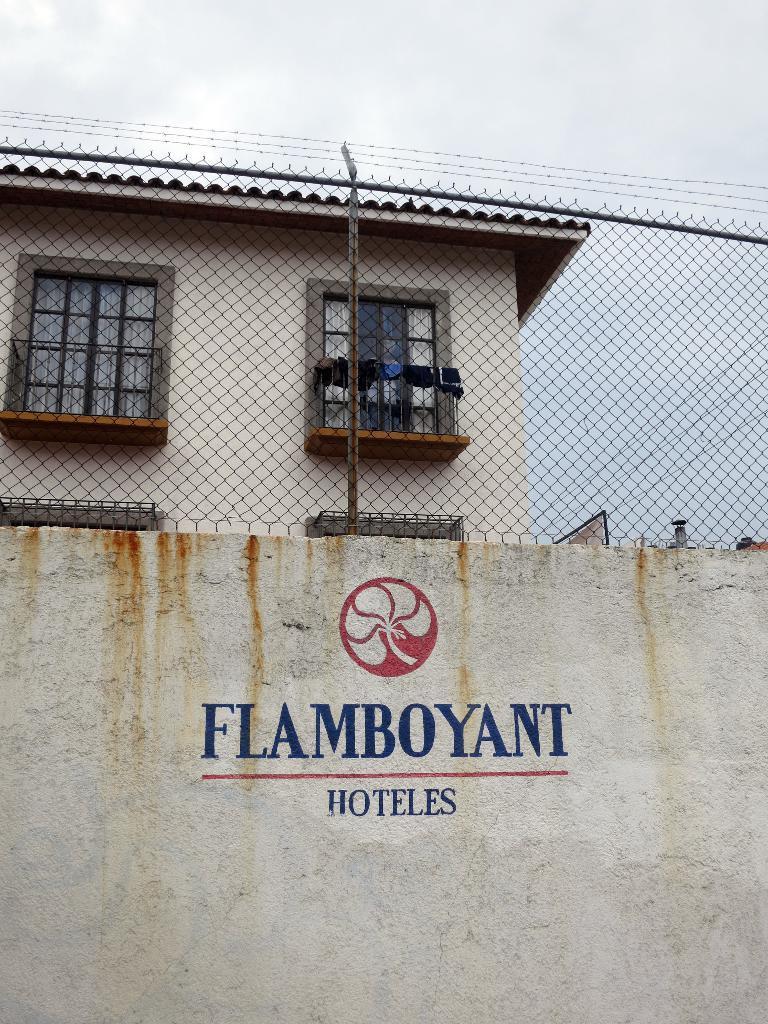How would you summarize this image in a sentence or two? In the foreground of this image, there is some text on a wall. At the top, there is a mesh. Behind it, there is a building and the sky. 